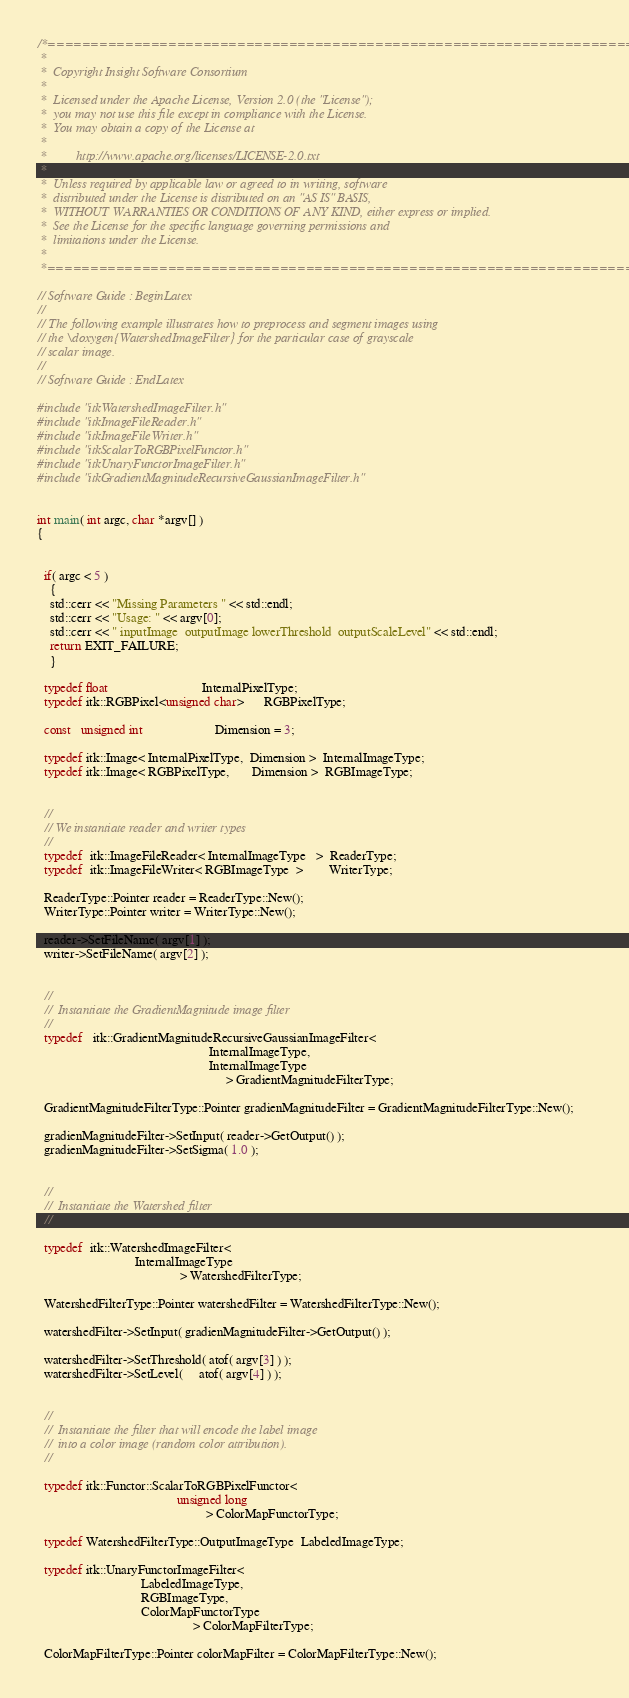Convert code to text. <code><loc_0><loc_0><loc_500><loc_500><_C++_>/*=========================================================================
 *
 *  Copyright Insight Software Consortium
 *
 *  Licensed under the Apache License, Version 2.0 (the "License");
 *  you may not use this file except in compliance with the License.
 *  You may obtain a copy of the License at
 *
 *         http://www.apache.org/licenses/LICENSE-2.0.txt
 *
 *  Unless required by applicable law or agreed to in writing, software
 *  distributed under the License is distributed on an "AS IS" BASIS,
 *  WITHOUT WARRANTIES OR CONDITIONS OF ANY KIND, either express or implied.
 *  See the License for the specific language governing permissions and
 *  limitations under the License.
 *
 *=========================================================================*/

// Software Guide : BeginLatex
//
// The following example illustrates how to preprocess and segment images using
// the \doxygen{WatershedImageFilter} for the particular case of grayscale
// scalar image.
//
// Software Guide : EndLatex

#include "itkWatershedImageFilter.h"
#include "itkImageFileReader.h"
#include "itkImageFileWriter.h"
#include "itkScalarToRGBPixelFunctor.h"
#include "itkUnaryFunctorImageFilter.h"
#include "itkGradientMagnitudeRecursiveGaussianImageFilter.h"


int main( int argc, char *argv[] )
{


  if( argc < 5 )
    {
    std::cerr << "Missing Parameters " << std::endl;
    std::cerr << "Usage: " << argv[0];
    std::cerr << " inputImage  outputImage lowerThreshold  outputScaleLevel" << std::endl;
    return EXIT_FAILURE;
    }

  typedef float                             InternalPixelType;
  typedef itk::RGBPixel<unsigned char>      RGBPixelType;

  const   unsigned int                      Dimension = 3;

  typedef itk::Image< InternalPixelType,  Dimension >  InternalImageType;
  typedef itk::Image< RGBPixelType,       Dimension >  RGBImageType;


  //
  // We instantiate reader and writer types
  //
  typedef  itk::ImageFileReader< InternalImageType   >  ReaderType;
  typedef  itk::ImageFileWriter< RGBImageType  >        WriterType;

  ReaderType::Pointer reader = ReaderType::New();
  WriterType::Pointer writer = WriterType::New();

  reader->SetFileName( argv[1] );
  writer->SetFileName( argv[2] );


  //
  //  Instantiate the GradientMagnitude image filter
  //
  typedef   itk::GradientMagnitudeRecursiveGaussianImageFilter<
                                                     InternalImageType,
                                                     InternalImageType
                                                          > GradientMagnitudeFilterType;

  GradientMagnitudeFilterType::Pointer gradienMagnitudeFilter = GradientMagnitudeFilterType::New();

  gradienMagnitudeFilter->SetInput( reader->GetOutput() );
  gradienMagnitudeFilter->SetSigma( 1.0 );


  //
  //  Instantiate the Watershed filter
  //

  typedef  itk::WatershedImageFilter<
                              InternalImageType
                                            > WatershedFilterType;

  WatershedFilterType::Pointer watershedFilter = WatershedFilterType::New();

  watershedFilter->SetInput( gradienMagnitudeFilter->GetOutput() );

  watershedFilter->SetThreshold( atof( argv[3] ) );
  watershedFilter->SetLevel(     atof( argv[4] ) );


  //
  //  Instantiate the filter that will encode the label image
  //  into a color image (random color attribution).
  //

  typedef itk::Functor::ScalarToRGBPixelFunctor<
                                           unsigned long
                                                    > ColorMapFunctorType;

  typedef WatershedFilterType::OutputImageType  LabeledImageType;

  typedef itk::UnaryFunctorImageFilter<
                                LabeledImageType,
                                RGBImageType,
                                ColorMapFunctorType
                                                > ColorMapFilterType;

  ColorMapFilterType::Pointer colorMapFilter = ColorMapFilterType::New();
</code> 